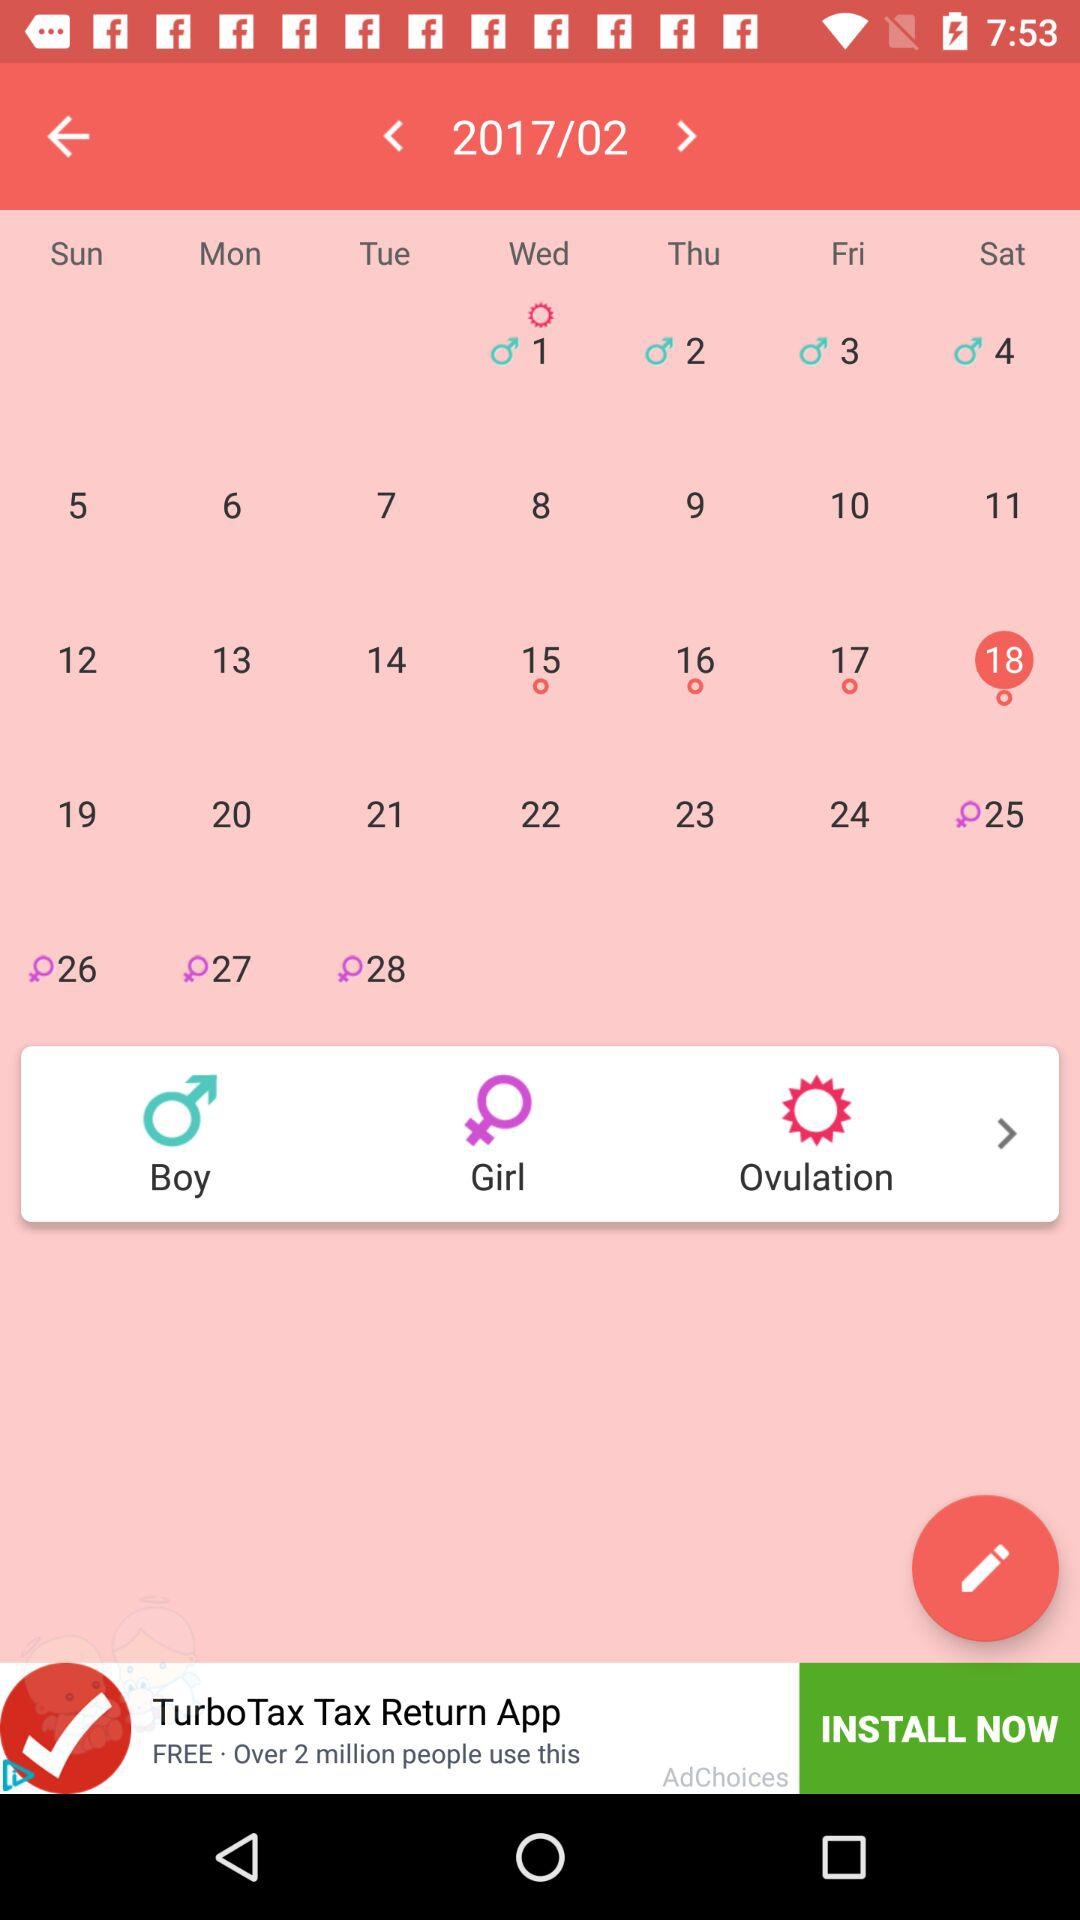What is the calendar month? The calendar month is February. 